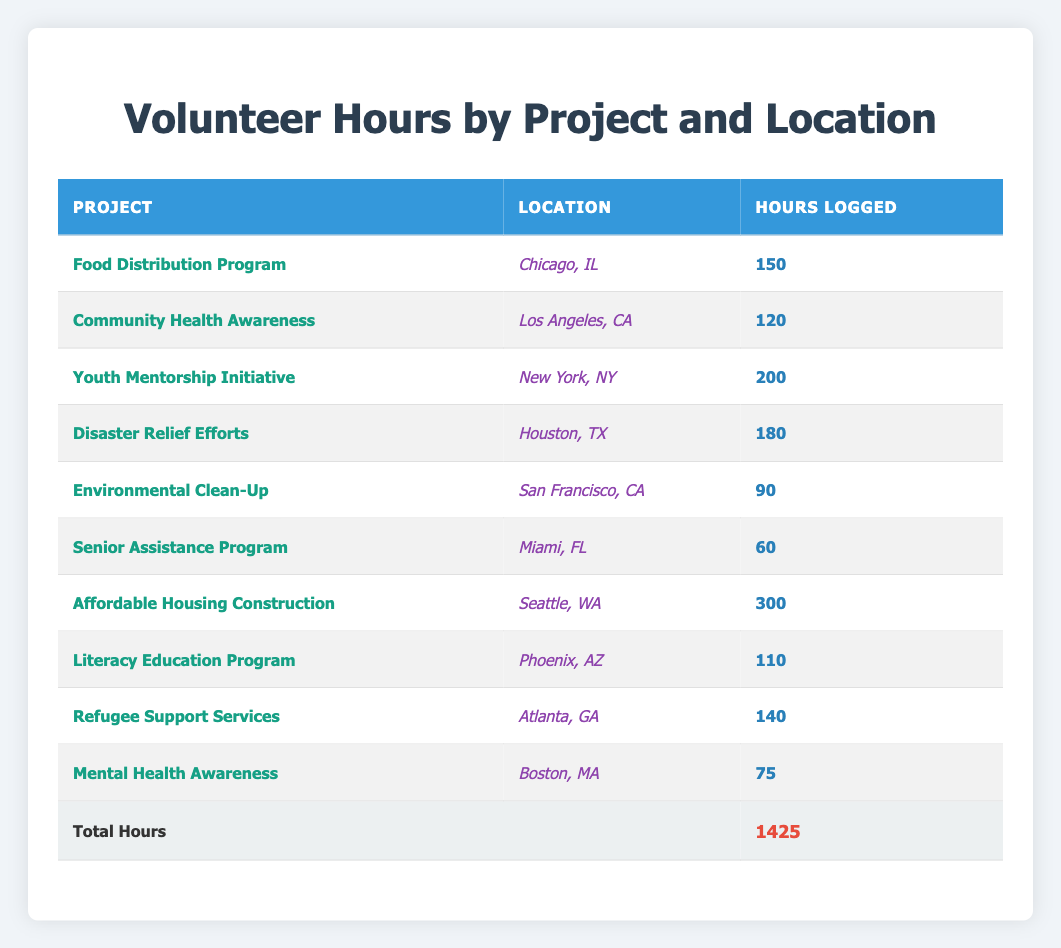What project logged the most volunteer hours? The project with the most hours logged can be found by reviewing the "Hours Logged" column. Looking at the values, "Affordable Housing Construction" has logged 300 hours, which is the highest compared to other projects.
Answer: Affordable Housing Construction Which location had the least logged volunteer hours? To find the location with the least hours, check the "Hours Logged" column and identify the lowest value. "Senior Assistance Program" in Miami, FL, logged only 60 hours, making it the least.
Answer: Miami, FL How many total hours were logged across all projects? The total hours logged can be calculated by adding the hours from each row and it is given in the last row of the table as 1425 hours.
Answer: 1425 What is the average number of volunteer hours logged per project? There are 10 projects listed in the table. To find the average, we divide the total logged hours (1425) by the number of projects (10). Thus, 1425 / 10 equals 142.5.
Answer: 142.5 Did any project log more than 200 hours? We need to check the "Hours Logged" values to determine if any project exceeds 200. It shows "Youth Mentorship Initiative" with 200 hours and "Affordable Housing Construction" with 300 hours, confirming that these projects logged more than 200 hours.
Answer: Yes What is the total logged hours for projects located in California? Reviewing the table, we find "Community Health Awareness" with 120 hours and "Environmental Clean-Up" with 90 hours in California. Adding these together gives 120 + 90 = 210 hours.
Answer: 210 Which project in Houston logged volunteer hours? The table lists "Disaster Relief Efforts" under the Houston, TX location with 180 hours logged.
Answer: Disaster Relief Efforts Is there any project that logged exactly 150 hours? From the "Hours Logged" column, we verify that the "Food Distribution Program" logged 150 hours, therefore the answer is yes.
Answer: Yes What are the total hours logged for all projects in the Midwest region? The Midwest projects include "Food Distribution Program" (150 hours in Chicago, IL) and "Disaster Relief Efforts" (180 hours in Houston, TX). Adding these gives us total hours of 150 + 180 = 330.
Answer: 330 